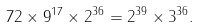Convert formula to latex. <formula><loc_0><loc_0><loc_500><loc_500>7 2 \times 9 ^ { 1 7 } \times 2 ^ { 3 6 } = 2 ^ { 3 9 } \times 3 ^ { 3 6 } .</formula> 